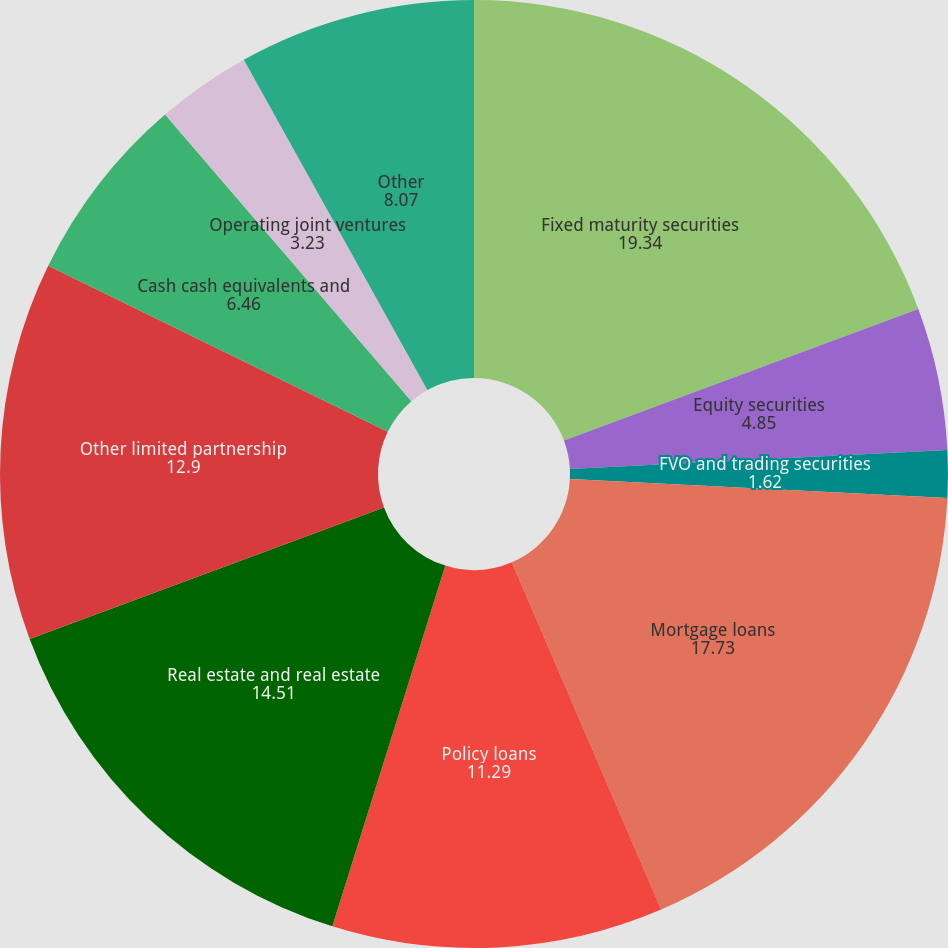<chart> <loc_0><loc_0><loc_500><loc_500><pie_chart><fcel>Fixed maturity securities<fcel>Equity securities<fcel>FVO and trading securities<fcel>Mortgage loans<fcel>Policy loans<fcel>Real estate and real estate<fcel>Other limited partnership<fcel>Cash cash equivalents and<fcel>Operating joint ventures<fcel>Other<nl><fcel>19.34%<fcel>4.85%<fcel>1.62%<fcel>17.73%<fcel>11.29%<fcel>14.51%<fcel>12.9%<fcel>6.46%<fcel>3.23%<fcel>8.07%<nl></chart> 